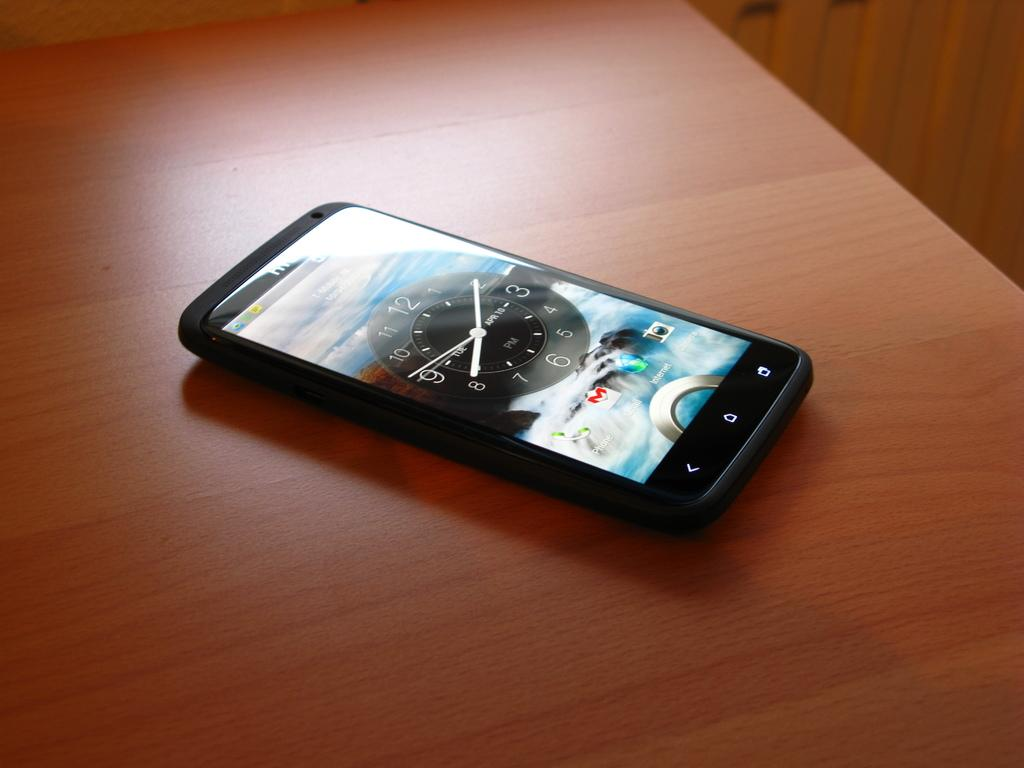<image>
Describe the image concisely. A smartphone shows an analog clock showing the date. 